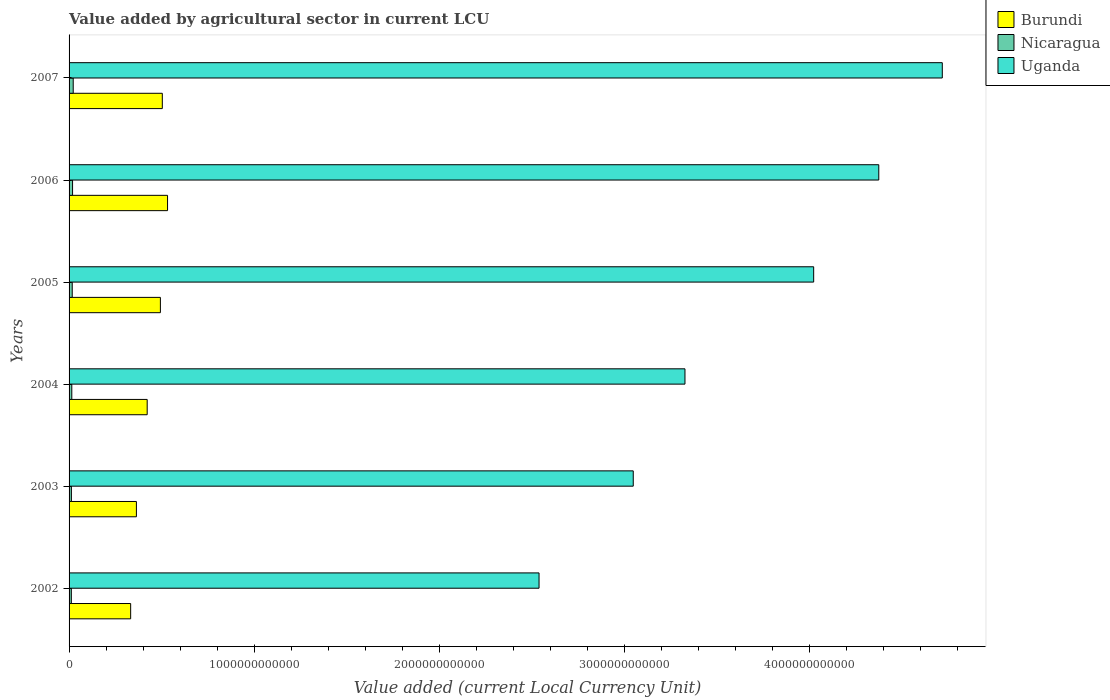How many different coloured bars are there?
Your answer should be compact. 3. Are the number of bars per tick equal to the number of legend labels?
Offer a terse response. Yes. How many bars are there on the 6th tick from the bottom?
Your answer should be compact. 3. What is the value added by agricultural sector in Nicaragua in 2004?
Offer a terse response. 1.47e+1. Across all years, what is the maximum value added by agricultural sector in Burundi?
Give a very brief answer. 5.32e+11. Across all years, what is the minimum value added by agricultural sector in Burundi?
Your answer should be compact. 3.33e+11. What is the total value added by agricultural sector in Nicaragua in the graph?
Your answer should be compact. 9.79e+1. What is the difference between the value added by agricultural sector in Burundi in 2005 and that in 2006?
Provide a short and direct response. -3.87e+1. What is the difference between the value added by agricultural sector in Nicaragua in 2007 and the value added by agricultural sector in Burundi in 2003?
Give a very brief answer. -3.42e+11. What is the average value added by agricultural sector in Burundi per year?
Your answer should be compact. 4.41e+11. In the year 2005, what is the difference between the value added by agricultural sector in Uganda and value added by agricultural sector in Nicaragua?
Ensure brevity in your answer.  4.01e+12. In how many years, is the value added by agricultural sector in Burundi greater than 800000000000 LCU?
Make the answer very short. 0. What is the ratio of the value added by agricultural sector in Nicaragua in 2002 to that in 2005?
Provide a succinct answer. 0.72. Is the value added by agricultural sector in Burundi in 2002 less than that in 2007?
Your answer should be compact. Yes. What is the difference between the highest and the second highest value added by agricultural sector in Nicaragua?
Keep it short and to the point. 3.51e+09. What is the difference between the highest and the lowest value added by agricultural sector in Uganda?
Give a very brief answer. 2.18e+12. In how many years, is the value added by agricultural sector in Burundi greater than the average value added by agricultural sector in Burundi taken over all years?
Ensure brevity in your answer.  3. Is the sum of the value added by agricultural sector in Burundi in 2002 and 2003 greater than the maximum value added by agricultural sector in Uganda across all years?
Make the answer very short. No. What does the 2nd bar from the top in 2006 represents?
Give a very brief answer. Nicaragua. What does the 3rd bar from the bottom in 2003 represents?
Offer a terse response. Uganda. What is the difference between two consecutive major ticks on the X-axis?
Your answer should be very brief. 1.00e+12. Where does the legend appear in the graph?
Make the answer very short. Top right. How many legend labels are there?
Provide a succinct answer. 3. What is the title of the graph?
Your response must be concise. Value added by agricultural sector in current LCU. What is the label or title of the X-axis?
Make the answer very short. Value added (current Local Currency Unit). What is the label or title of the Y-axis?
Keep it short and to the point. Years. What is the Value added (current Local Currency Unit) in Burundi in 2002?
Your answer should be compact. 3.33e+11. What is the Value added (current Local Currency Unit) of Nicaragua in 2002?
Your answer should be compact. 1.22e+1. What is the Value added (current Local Currency Unit) of Uganda in 2002?
Make the answer very short. 2.54e+12. What is the Value added (current Local Currency Unit) in Burundi in 2003?
Give a very brief answer. 3.64e+11. What is the Value added (current Local Currency Unit) of Nicaragua in 2003?
Offer a very short reply. 1.26e+1. What is the Value added (current Local Currency Unit) of Uganda in 2003?
Give a very brief answer. 3.05e+12. What is the Value added (current Local Currency Unit) of Burundi in 2004?
Offer a terse response. 4.22e+11. What is the Value added (current Local Currency Unit) in Nicaragua in 2004?
Give a very brief answer. 1.47e+1. What is the Value added (current Local Currency Unit) of Uganda in 2004?
Your answer should be very brief. 3.33e+12. What is the Value added (current Local Currency Unit) of Burundi in 2005?
Keep it short and to the point. 4.94e+11. What is the Value added (current Local Currency Unit) in Nicaragua in 2005?
Keep it short and to the point. 1.71e+1. What is the Value added (current Local Currency Unit) in Uganda in 2005?
Your answer should be very brief. 4.02e+12. What is the Value added (current Local Currency Unit) of Burundi in 2006?
Provide a succinct answer. 5.32e+11. What is the Value added (current Local Currency Unit) of Nicaragua in 2006?
Provide a succinct answer. 1.89e+1. What is the Value added (current Local Currency Unit) in Uganda in 2006?
Your answer should be compact. 4.38e+12. What is the Value added (current Local Currency Unit) of Burundi in 2007?
Provide a short and direct response. 5.04e+11. What is the Value added (current Local Currency Unit) in Nicaragua in 2007?
Offer a very short reply. 2.24e+1. What is the Value added (current Local Currency Unit) in Uganda in 2007?
Make the answer very short. 4.72e+12. Across all years, what is the maximum Value added (current Local Currency Unit) in Burundi?
Offer a terse response. 5.32e+11. Across all years, what is the maximum Value added (current Local Currency Unit) in Nicaragua?
Provide a succinct answer. 2.24e+1. Across all years, what is the maximum Value added (current Local Currency Unit) of Uganda?
Provide a short and direct response. 4.72e+12. Across all years, what is the minimum Value added (current Local Currency Unit) in Burundi?
Ensure brevity in your answer.  3.33e+11. Across all years, what is the minimum Value added (current Local Currency Unit) in Nicaragua?
Ensure brevity in your answer.  1.22e+1. Across all years, what is the minimum Value added (current Local Currency Unit) in Uganda?
Keep it short and to the point. 2.54e+12. What is the total Value added (current Local Currency Unit) of Burundi in the graph?
Provide a short and direct response. 2.65e+12. What is the total Value added (current Local Currency Unit) in Nicaragua in the graph?
Your response must be concise. 9.79e+1. What is the total Value added (current Local Currency Unit) of Uganda in the graph?
Offer a terse response. 2.20e+13. What is the difference between the Value added (current Local Currency Unit) of Burundi in 2002 and that in 2003?
Offer a terse response. -3.10e+1. What is the difference between the Value added (current Local Currency Unit) of Nicaragua in 2002 and that in 2003?
Offer a very short reply. -3.30e+08. What is the difference between the Value added (current Local Currency Unit) of Uganda in 2002 and that in 2003?
Make the answer very short. -5.09e+11. What is the difference between the Value added (current Local Currency Unit) of Burundi in 2002 and that in 2004?
Ensure brevity in your answer.  -8.93e+1. What is the difference between the Value added (current Local Currency Unit) in Nicaragua in 2002 and that in 2004?
Your answer should be compact. -2.51e+09. What is the difference between the Value added (current Local Currency Unit) in Uganda in 2002 and that in 2004?
Your response must be concise. -7.89e+11. What is the difference between the Value added (current Local Currency Unit) in Burundi in 2002 and that in 2005?
Provide a short and direct response. -1.61e+11. What is the difference between the Value added (current Local Currency Unit) of Nicaragua in 2002 and that in 2005?
Offer a very short reply. -4.84e+09. What is the difference between the Value added (current Local Currency Unit) in Uganda in 2002 and that in 2005?
Keep it short and to the point. -1.48e+12. What is the difference between the Value added (current Local Currency Unit) of Burundi in 2002 and that in 2006?
Your answer should be very brief. -1.99e+11. What is the difference between the Value added (current Local Currency Unit) of Nicaragua in 2002 and that in 2006?
Offer a very short reply. -6.65e+09. What is the difference between the Value added (current Local Currency Unit) in Uganda in 2002 and that in 2006?
Give a very brief answer. -1.84e+12. What is the difference between the Value added (current Local Currency Unit) in Burundi in 2002 and that in 2007?
Provide a short and direct response. -1.71e+11. What is the difference between the Value added (current Local Currency Unit) in Nicaragua in 2002 and that in 2007?
Your answer should be very brief. -1.02e+1. What is the difference between the Value added (current Local Currency Unit) of Uganda in 2002 and that in 2007?
Provide a succinct answer. -2.18e+12. What is the difference between the Value added (current Local Currency Unit) in Burundi in 2003 and that in 2004?
Give a very brief answer. -5.83e+1. What is the difference between the Value added (current Local Currency Unit) of Nicaragua in 2003 and that in 2004?
Provide a short and direct response. -2.18e+09. What is the difference between the Value added (current Local Currency Unit) in Uganda in 2003 and that in 2004?
Give a very brief answer. -2.80e+11. What is the difference between the Value added (current Local Currency Unit) in Burundi in 2003 and that in 2005?
Provide a short and direct response. -1.30e+11. What is the difference between the Value added (current Local Currency Unit) of Nicaragua in 2003 and that in 2005?
Your response must be concise. -4.51e+09. What is the difference between the Value added (current Local Currency Unit) in Uganda in 2003 and that in 2005?
Your answer should be compact. -9.75e+11. What is the difference between the Value added (current Local Currency Unit) in Burundi in 2003 and that in 2006?
Keep it short and to the point. -1.68e+11. What is the difference between the Value added (current Local Currency Unit) in Nicaragua in 2003 and that in 2006?
Offer a terse response. -6.32e+09. What is the difference between the Value added (current Local Currency Unit) of Uganda in 2003 and that in 2006?
Your answer should be very brief. -1.33e+12. What is the difference between the Value added (current Local Currency Unit) in Burundi in 2003 and that in 2007?
Keep it short and to the point. -1.40e+11. What is the difference between the Value added (current Local Currency Unit) in Nicaragua in 2003 and that in 2007?
Make the answer very short. -9.83e+09. What is the difference between the Value added (current Local Currency Unit) of Uganda in 2003 and that in 2007?
Make the answer very short. -1.67e+12. What is the difference between the Value added (current Local Currency Unit) in Burundi in 2004 and that in 2005?
Give a very brief answer. -7.14e+1. What is the difference between the Value added (current Local Currency Unit) of Nicaragua in 2004 and that in 2005?
Your answer should be compact. -2.33e+09. What is the difference between the Value added (current Local Currency Unit) in Uganda in 2004 and that in 2005?
Offer a very short reply. -6.96e+11. What is the difference between the Value added (current Local Currency Unit) in Burundi in 2004 and that in 2006?
Provide a short and direct response. -1.10e+11. What is the difference between the Value added (current Local Currency Unit) of Nicaragua in 2004 and that in 2006?
Your response must be concise. -4.14e+09. What is the difference between the Value added (current Local Currency Unit) in Uganda in 2004 and that in 2006?
Offer a terse response. -1.05e+12. What is the difference between the Value added (current Local Currency Unit) in Burundi in 2004 and that in 2007?
Provide a succinct answer. -8.18e+1. What is the difference between the Value added (current Local Currency Unit) of Nicaragua in 2004 and that in 2007?
Your answer should be compact. -7.65e+09. What is the difference between the Value added (current Local Currency Unit) of Uganda in 2004 and that in 2007?
Provide a short and direct response. -1.39e+12. What is the difference between the Value added (current Local Currency Unit) in Burundi in 2005 and that in 2006?
Your response must be concise. -3.87e+1. What is the difference between the Value added (current Local Currency Unit) in Nicaragua in 2005 and that in 2006?
Your response must be concise. -1.81e+09. What is the difference between the Value added (current Local Currency Unit) of Uganda in 2005 and that in 2006?
Make the answer very short. -3.52e+11. What is the difference between the Value added (current Local Currency Unit) of Burundi in 2005 and that in 2007?
Keep it short and to the point. -1.04e+1. What is the difference between the Value added (current Local Currency Unit) in Nicaragua in 2005 and that in 2007?
Make the answer very short. -5.32e+09. What is the difference between the Value added (current Local Currency Unit) in Uganda in 2005 and that in 2007?
Provide a succinct answer. -6.95e+11. What is the difference between the Value added (current Local Currency Unit) in Burundi in 2006 and that in 2007?
Provide a succinct answer. 2.83e+1. What is the difference between the Value added (current Local Currency Unit) of Nicaragua in 2006 and that in 2007?
Provide a succinct answer. -3.51e+09. What is the difference between the Value added (current Local Currency Unit) of Uganda in 2006 and that in 2007?
Offer a terse response. -3.43e+11. What is the difference between the Value added (current Local Currency Unit) in Burundi in 2002 and the Value added (current Local Currency Unit) in Nicaragua in 2003?
Your answer should be very brief. 3.20e+11. What is the difference between the Value added (current Local Currency Unit) of Burundi in 2002 and the Value added (current Local Currency Unit) of Uganda in 2003?
Your answer should be compact. -2.72e+12. What is the difference between the Value added (current Local Currency Unit) of Nicaragua in 2002 and the Value added (current Local Currency Unit) of Uganda in 2003?
Offer a very short reply. -3.04e+12. What is the difference between the Value added (current Local Currency Unit) of Burundi in 2002 and the Value added (current Local Currency Unit) of Nicaragua in 2004?
Your answer should be compact. 3.18e+11. What is the difference between the Value added (current Local Currency Unit) of Burundi in 2002 and the Value added (current Local Currency Unit) of Uganda in 2004?
Your answer should be compact. -3.00e+12. What is the difference between the Value added (current Local Currency Unit) in Nicaragua in 2002 and the Value added (current Local Currency Unit) in Uganda in 2004?
Ensure brevity in your answer.  -3.32e+12. What is the difference between the Value added (current Local Currency Unit) in Burundi in 2002 and the Value added (current Local Currency Unit) in Nicaragua in 2005?
Keep it short and to the point. 3.16e+11. What is the difference between the Value added (current Local Currency Unit) of Burundi in 2002 and the Value added (current Local Currency Unit) of Uganda in 2005?
Provide a succinct answer. -3.69e+12. What is the difference between the Value added (current Local Currency Unit) in Nicaragua in 2002 and the Value added (current Local Currency Unit) in Uganda in 2005?
Your answer should be compact. -4.01e+12. What is the difference between the Value added (current Local Currency Unit) in Burundi in 2002 and the Value added (current Local Currency Unit) in Nicaragua in 2006?
Your answer should be very brief. 3.14e+11. What is the difference between the Value added (current Local Currency Unit) in Burundi in 2002 and the Value added (current Local Currency Unit) in Uganda in 2006?
Your response must be concise. -4.04e+12. What is the difference between the Value added (current Local Currency Unit) in Nicaragua in 2002 and the Value added (current Local Currency Unit) in Uganda in 2006?
Provide a succinct answer. -4.36e+12. What is the difference between the Value added (current Local Currency Unit) in Burundi in 2002 and the Value added (current Local Currency Unit) in Nicaragua in 2007?
Provide a short and direct response. 3.11e+11. What is the difference between the Value added (current Local Currency Unit) of Burundi in 2002 and the Value added (current Local Currency Unit) of Uganda in 2007?
Give a very brief answer. -4.39e+12. What is the difference between the Value added (current Local Currency Unit) of Nicaragua in 2002 and the Value added (current Local Currency Unit) of Uganda in 2007?
Give a very brief answer. -4.71e+12. What is the difference between the Value added (current Local Currency Unit) of Burundi in 2003 and the Value added (current Local Currency Unit) of Nicaragua in 2004?
Offer a very short reply. 3.49e+11. What is the difference between the Value added (current Local Currency Unit) of Burundi in 2003 and the Value added (current Local Currency Unit) of Uganda in 2004?
Give a very brief answer. -2.97e+12. What is the difference between the Value added (current Local Currency Unit) in Nicaragua in 2003 and the Value added (current Local Currency Unit) in Uganda in 2004?
Your answer should be compact. -3.32e+12. What is the difference between the Value added (current Local Currency Unit) of Burundi in 2003 and the Value added (current Local Currency Unit) of Nicaragua in 2005?
Offer a terse response. 3.47e+11. What is the difference between the Value added (current Local Currency Unit) in Burundi in 2003 and the Value added (current Local Currency Unit) in Uganda in 2005?
Your answer should be very brief. -3.66e+12. What is the difference between the Value added (current Local Currency Unit) of Nicaragua in 2003 and the Value added (current Local Currency Unit) of Uganda in 2005?
Your response must be concise. -4.01e+12. What is the difference between the Value added (current Local Currency Unit) in Burundi in 2003 and the Value added (current Local Currency Unit) in Nicaragua in 2006?
Your answer should be compact. 3.45e+11. What is the difference between the Value added (current Local Currency Unit) in Burundi in 2003 and the Value added (current Local Currency Unit) in Uganda in 2006?
Offer a terse response. -4.01e+12. What is the difference between the Value added (current Local Currency Unit) of Nicaragua in 2003 and the Value added (current Local Currency Unit) of Uganda in 2006?
Provide a succinct answer. -4.36e+12. What is the difference between the Value added (current Local Currency Unit) in Burundi in 2003 and the Value added (current Local Currency Unit) in Nicaragua in 2007?
Your response must be concise. 3.42e+11. What is the difference between the Value added (current Local Currency Unit) in Burundi in 2003 and the Value added (current Local Currency Unit) in Uganda in 2007?
Your answer should be compact. -4.36e+12. What is the difference between the Value added (current Local Currency Unit) in Nicaragua in 2003 and the Value added (current Local Currency Unit) in Uganda in 2007?
Make the answer very short. -4.71e+12. What is the difference between the Value added (current Local Currency Unit) in Burundi in 2004 and the Value added (current Local Currency Unit) in Nicaragua in 2005?
Keep it short and to the point. 4.05e+11. What is the difference between the Value added (current Local Currency Unit) of Burundi in 2004 and the Value added (current Local Currency Unit) of Uganda in 2005?
Offer a terse response. -3.60e+12. What is the difference between the Value added (current Local Currency Unit) in Nicaragua in 2004 and the Value added (current Local Currency Unit) in Uganda in 2005?
Keep it short and to the point. -4.01e+12. What is the difference between the Value added (current Local Currency Unit) in Burundi in 2004 and the Value added (current Local Currency Unit) in Nicaragua in 2006?
Provide a succinct answer. 4.03e+11. What is the difference between the Value added (current Local Currency Unit) of Burundi in 2004 and the Value added (current Local Currency Unit) of Uganda in 2006?
Ensure brevity in your answer.  -3.95e+12. What is the difference between the Value added (current Local Currency Unit) of Nicaragua in 2004 and the Value added (current Local Currency Unit) of Uganda in 2006?
Your answer should be very brief. -4.36e+12. What is the difference between the Value added (current Local Currency Unit) of Burundi in 2004 and the Value added (current Local Currency Unit) of Nicaragua in 2007?
Ensure brevity in your answer.  4.00e+11. What is the difference between the Value added (current Local Currency Unit) in Burundi in 2004 and the Value added (current Local Currency Unit) in Uganda in 2007?
Ensure brevity in your answer.  -4.30e+12. What is the difference between the Value added (current Local Currency Unit) in Nicaragua in 2004 and the Value added (current Local Currency Unit) in Uganda in 2007?
Make the answer very short. -4.71e+12. What is the difference between the Value added (current Local Currency Unit) of Burundi in 2005 and the Value added (current Local Currency Unit) of Nicaragua in 2006?
Provide a short and direct response. 4.75e+11. What is the difference between the Value added (current Local Currency Unit) of Burundi in 2005 and the Value added (current Local Currency Unit) of Uganda in 2006?
Give a very brief answer. -3.88e+12. What is the difference between the Value added (current Local Currency Unit) of Nicaragua in 2005 and the Value added (current Local Currency Unit) of Uganda in 2006?
Your response must be concise. -4.36e+12. What is the difference between the Value added (current Local Currency Unit) of Burundi in 2005 and the Value added (current Local Currency Unit) of Nicaragua in 2007?
Offer a terse response. 4.71e+11. What is the difference between the Value added (current Local Currency Unit) of Burundi in 2005 and the Value added (current Local Currency Unit) of Uganda in 2007?
Your answer should be very brief. -4.23e+12. What is the difference between the Value added (current Local Currency Unit) of Nicaragua in 2005 and the Value added (current Local Currency Unit) of Uganda in 2007?
Your response must be concise. -4.70e+12. What is the difference between the Value added (current Local Currency Unit) in Burundi in 2006 and the Value added (current Local Currency Unit) in Nicaragua in 2007?
Keep it short and to the point. 5.10e+11. What is the difference between the Value added (current Local Currency Unit) in Burundi in 2006 and the Value added (current Local Currency Unit) in Uganda in 2007?
Provide a succinct answer. -4.19e+12. What is the difference between the Value added (current Local Currency Unit) of Nicaragua in 2006 and the Value added (current Local Currency Unit) of Uganda in 2007?
Offer a very short reply. -4.70e+12. What is the average Value added (current Local Currency Unit) in Burundi per year?
Your answer should be compact. 4.41e+11. What is the average Value added (current Local Currency Unit) in Nicaragua per year?
Your answer should be compact. 1.63e+1. What is the average Value added (current Local Currency Unit) of Uganda per year?
Provide a succinct answer. 3.67e+12. In the year 2002, what is the difference between the Value added (current Local Currency Unit) of Burundi and Value added (current Local Currency Unit) of Nicaragua?
Offer a very short reply. 3.21e+11. In the year 2002, what is the difference between the Value added (current Local Currency Unit) in Burundi and Value added (current Local Currency Unit) in Uganda?
Ensure brevity in your answer.  -2.21e+12. In the year 2002, what is the difference between the Value added (current Local Currency Unit) in Nicaragua and Value added (current Local Currency Unit) in Uganda?
Your response must be concise. -2.53e+12. In the year 2003, what is the difference between the Value added (current Local Currency Unit) in Burundi and Value added (current Local Currency Unit) in Nicaragua?
Provide a short and direct response. 3.51e+11. In the year 2003, what is the difference between the Value added (current Local Currency Unit) of Burundi and Value added (current Local Currency Unit) of Uganda?
Your response must be concise. -2.69e+12. In the year 2003, what is the difference between the Value added (current Local Currency Unit) in Nicaragua and Value added (current Local Currency Unit) in Uganda?
Your answer should be compact. -3.04e+12. In the year 2004, what is the difference between the Value added (current Local Currency Unit) in Burundi and Value added (current Local Currency Unit) in Nicaragua?
Keep it short and to the point. 4.07e+11. In the year 2004, what is the difference between the Value added (current Local Currency Unit) in Burundi and Value added (current Local Currency Unit) in Uganda?
Keep it short and to the point. -2.91e+12. In the year 2004, what is the difference between the Value added (current Local Currency Unit) in Nicaragua and Value added (current Local Currency Unit) in Uganda?
Offer a very short reply. -3.31e+12. In the year 2005, what is the difference between the Value added (current Local Currency Unit) in Burundi and Value added (current Local Currency Unit) in Nicaragua?
Keep it short and to the point. 4.77e+11. In the year 2005, what is the difference between the Value added (current Local Currency Unit) of Burundi and Value added (current Local Currency Unit) of Uganda?
Provide a succinct answer. -3.53e+12. In the year 2005, what is the difference between the Value added (current Local Currency Unit) in Nicaragua and Value added (current Local Currency Unit) in Uganda?
Offer a very short reply. -4.01e+12. In the year 2006, what is the difference between the Value added (current Local Currency Unit) in Burundi and Value added (current Local Currency Unit) in Nicaragua?
Keep it short and to the point. 5.13e+11. In the year 2006, what is the difference between the Value added (current Local Currency Unit) of Burundi and Value added (current Local Currency Unit) of Uganda?
Provide a succinct answer. -3.84e+12. In the year 2006, what is the difference between the Value added (current Local Currency Unit) in Nicaragua and Value added (current Local Currency Unit) in Uganda?
Offer a very short reply. -4.36e+12. In the year 2007, what is the difference between the Value added (current Local Currency Unit) of Burundi and Value added (current Local Currency Unit) of Nicaragua?
Your answer should be compact. 4.82e+11. In the year 2007, what is the difference between the Value added (current Local Currency Unit) of Burundi and Value added (current Local Currency Unit) of Uganda?
Offer a terse response. -4.22e+12. In the year 2007, what is the difference between the Value added (current Local Currency Unit) in Nicaragua and Value added (current Local Currency Unit) in Uganda?
Make the answer very short. -4.70e+12. What is the ratio of the Value added (current Local Currency Unit) of Burundi in 2002 to that in 2003?
Your response must be concise. 0.91. What is the ratio of the Value added (current Local Currency Unit) in Nicaragua in 2002 to that in 2003?
Ensure brevity in your answer.  0.97. What is the ratio of the Value added (current Local Currency Unit) in Uganda in 2002 to that in 2003?
Your response must be concise. 0.83. What is the ratio of the Value added (current Local Currency Unit) of Burundi in 2002 to that in 2004?
Ensure brevity in your answer.  0.79. What is the ratio of the Value added (current Local Currency Unit) in Nicaragua in 2002 to that in 2004?
Make the answer very short. 0.83. What is the ratio of the Value added (current Local Currency Unit) of Uganda in 2002 to that in 2004?
Offer a very short reply. 0.76. What is the ratio of the Value added (current Local Currency Unit) of Burundi in 2002 to that in 2005?
Provide a short and direct response. 0.67. What is the ratio of the Value added (current Local Currency Unit) in Nicaragua in 2002 to that in 2005?
Your response must be concise. 0.72. What is the ratio of the Value added (current Local Currency Unit) of Uganda in 2002 to that in 2005?
Provide a short and direct response. 0.63. What is the ratio of the Value added (current Local Currency Unit) in Burundi in 2002 to that in 2006?
Keep it short and to the point. 0.63. What is the ratio of the Value added (current Local Currency Unit) in Nicaragua in 2002 to that in 2006?
Provide a short and direct response. 0.65. What is the ratio of the Value added (current Local Currency Unit) in Uganda in 2002 to that in 2006?
Offer a terse response. 0.58. What is the ratio of the Value added (current Local Currency Unit) of Burundi in 2002 to that in 2007?
Give a very brief answer. 0.66. What is the ratio of the Value added (current Local Currency Unit) of Nicaragua in 2002 to that in 2007?
Your response must be concise. 0.55. What is the ratio of the Value added (current Local Currency Unit) of Uganda in 2002 to that in 2007?
Ensure brevity in your answer.  0.54. What is the ratio of the Value added (current Local Currency Unit) of Burundi in 2003 to that in 2004?
Keep it short and to the point. 0.86. What is the ratio of the Value added (current Local Currency Unit) of Nicaragua in 2003 to that in 2004?
Keep it short and to the point. 0.85. What is the ratio of the Value added (current Local Currency Unit) in Uganda in 2003 to that in 2004?
Provide a succinct answer. 0.92. What is the ratio of the Value added (current Local Currency Unit) in Burundi in 2003 to that in 2005?
Provide a succinct answer. 0.74. What is the ratio of the Value added (current Local Currency Unit) in Nicaragua in 2003 to that in 2005?
Ensure brevity in your answer.  0.74. What is the ratio of the Value added (current Local Currency Unit) of Uganda in 2003 to that in 2005?
Your response must be concise. 0.76. What is the ratio of the Value added (current Local Currency Unit) of Burundi in 2003 to that in 2006?
Your answer should be very brief. 0.68. What is the ratio of the Value added (current Local Currency Unit) in Nicaragua in 2003 to that in 2006?
Your response must be concise. 0.67. What is the ratio of the Value added (current Local Currency Unit) in Uganda in 2003 to that in 2006?
Your answer should be very brief. 0.7. What is the ratio of the Value added (current Local Currency Unit) of Burundi in 2003 to that in 2007?
Give a very brief answer. 0.72. What is the ratio of the Value added (current Local Currency Unit) of Nicaragua in 2003 to that in 2007?
Offer a terse response. 0.56. What is the ratio of the Value added (current Local Currency Unit) in Uganda in 2003 to that in 2007?
Keep it short and to the point. 0.65. What is the ratio of the Value added (current Local Currency Unit) of Burundi in 2004 to that in 2005?
Ensure brevity in your answer.  0.86. What is the ratio of the Value added (current Local Currency Unit) of Nicaragua in 2004 to that in 2005?
Ensure brevity in your answer.  0.86. What is the ratio of the Value added (current Local Currency Unit) of Uganda in 2004 to that in 2005?
Your answer should be compact. 0.83. What is the ratio of the Value added (current Local Currency Unit) of Burundi in 2004 to that in 2006?
Provide a succinct answer. 0.79. What is the ratio of the Value added (current Local Currency Unit) in Nicaragua in 2004 to that in 2006?
Your answer should be compact. 0.78. What is the ratio of the Value added (current Local Currency Unit) of Uganda in 2004 to that in 2006?
Offer a terse response. 0.76. What is the ratio of the Value added (current Local Currency Unit) in Burundi in 2004 to that in 2007?
Provide a succinct answer. 0.84. What is the ratio of the Value added (current Local Currency Unit) in Nicaragua in 2004 to that in 2007?
Provide a succinct answer. 0.66. What is the ratio of the Value added (current Local Currency Unit) of Uganda in 2004 to that in 2007?
Provide a short and direct response. 0.71. What is the ratio of the Value added (current Local Currency Unit) of Burundi in 2005 to that in 2006?
Keep it short and to the point. 0.93. What is the ratio of the Value added (current Local Currency Unit) in Nicaragua in 2005 to that in 2006?
Keep it short and to the point. 0.9. What is the ratio of the Value added (current Local Currency Unit) of Uganda in 2005 to that in 2006?
Give a very brief answer. 0.92. What is the ratio of the Value added (current Local Currency Unit) of Burundi in 2005 to that in 2007?
Offer a terse response. 0.98. What is the ratio of the Value added (current Local Currency Unit) of Nicaragua in 2005 to that in 2007?
Give a very brief answer. 0.76. What is the ratio of the Value added (current Local Currency Unit) of Uganda in 2005 to that in 2007?
Give a very brief answer. 0.85. What is the ratio of the Value added (current Local Currency Unit) of Burundi in 2006 to that in 2007?
Your answer should be very brief. 1.06. What is the ratio of the Value added (current Local Currency Unit) in Nicaragua in 2006 to that in 2007?
Give a very brief answer. 0.84. What is the ratio of the Value added (current Local Currency Unit) of Uganda in 2006 to that in 2007?
Your answer should be compact. 0.93. What is the difference between the highest and the second highest Value added (current Local Currency Unit) in Burundi?
Offer a terse response. 2.83e+1. What is the difference between the highest and the second highest Value added (current Local Currency Unit) in Nicaragua?
Provide a succinct answer. 3.51e+09. What is the difference between the highest and the second highest Value added (current Local Currency Unit) in Uganda?
Give a very brief answer. 3.43e+11. What is the difference between the highest and the lowest Value added (current Local Currency Unit) of Burundi?
Offer a terse response. 1.99e+11. What is the difference between the highest and the lowest Value added (current Local Currency Unit) in Nicaragua?
Give a very brief answer. 1.02e+1. What is the difference between the highest and the lowest Value added (current Local Currency Unit) of Uganda?
Ensure brevity in your answer.  2.18e+12. 